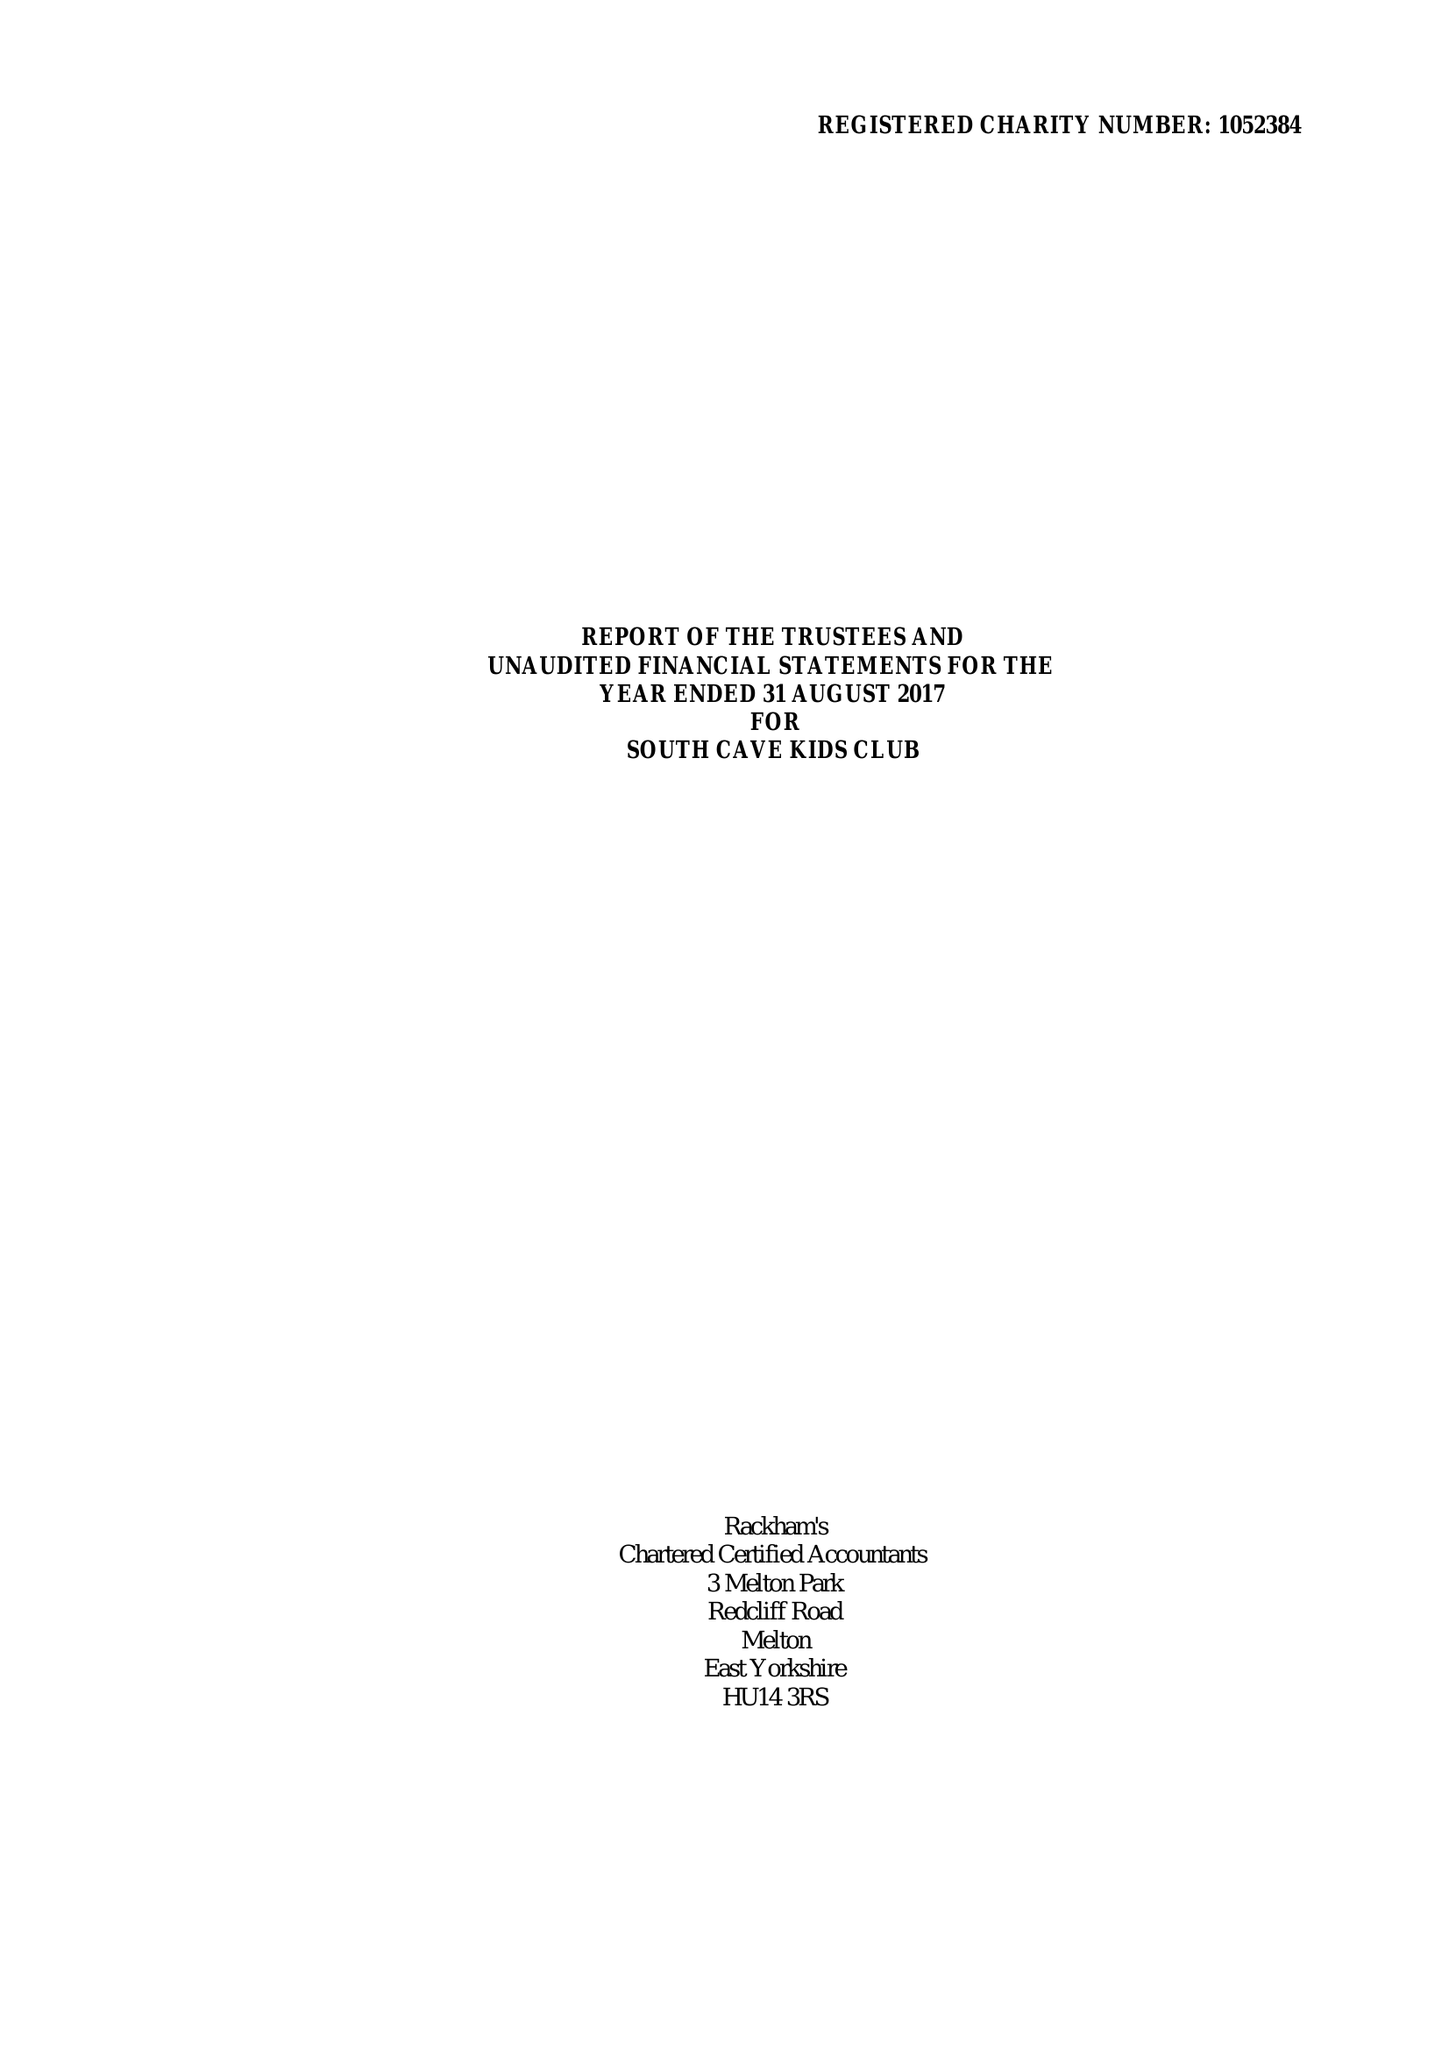What is the value for the charity_number?
Answer the question using a single word or phrase. 1052384 